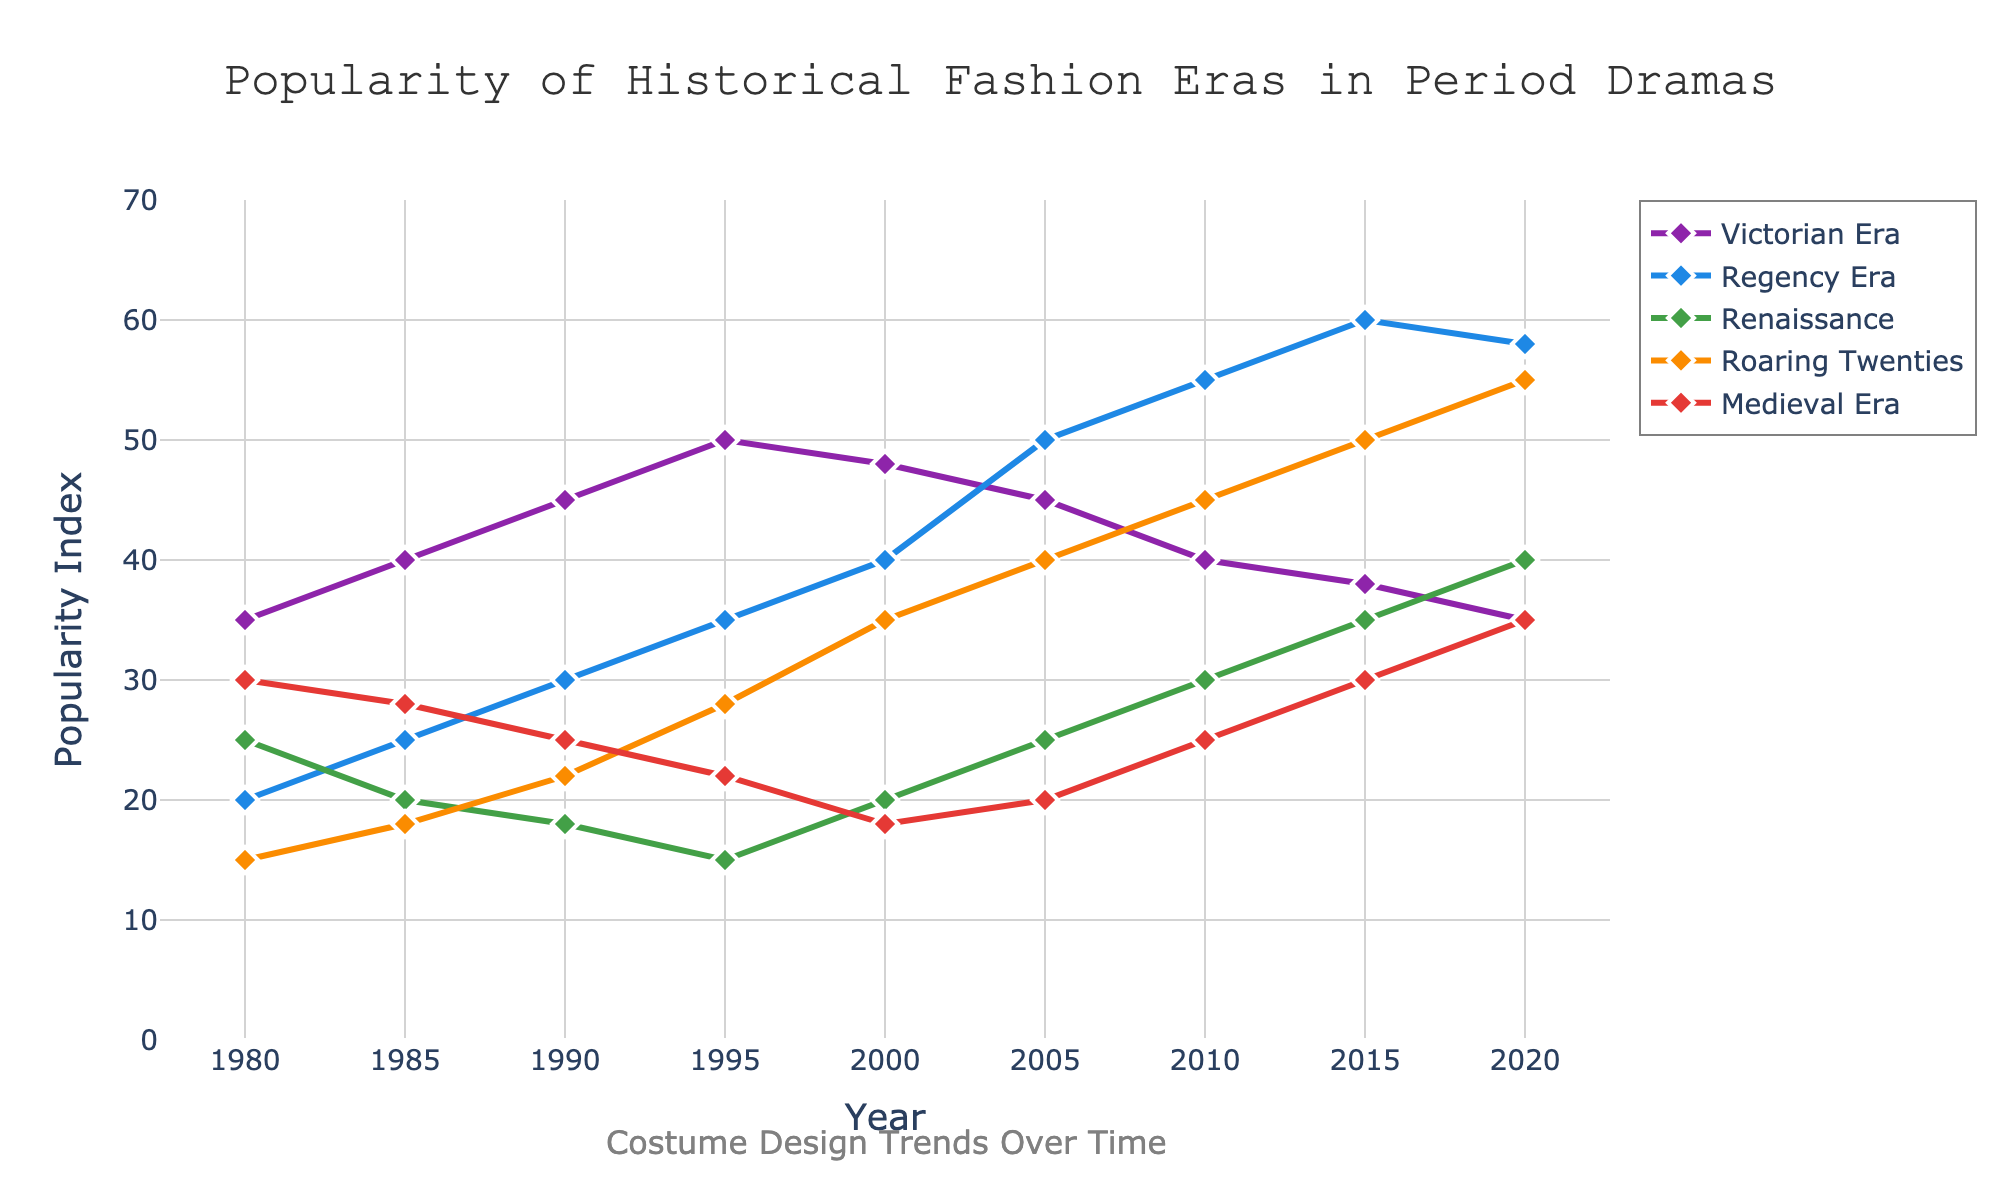What's the most popular fashion era in 2015? Based on the height of the lines at 2015, the Regency Era has the highest popularity index, where 60 is visibly the peak value.
Answer: Regency Era How does the popularity of the Roaring Twenties compare to the Medieval Era in 2020? By examining the endpoints of the lines in 2020, the Roaring Twenties fashion era has a higher popularity index of 55 compared to the Medieval Era’s index of 35.
Answer: Roaring Twenties is higher What year did the Victorian Era peak in popularity, and what was the index value? Observing the line for the Victorian Era, its highest point is in 1995, where the index value is 50.
Answer: 1995, 50 Which fashion era had a consistent increase in popularity from 1980 to 2015? Reviewing the overall trends for each line, the Regency Era shows a consistent increase from 20 in 1980 to 60 in 2015.
Answer: Regency Era What is the difference in popularity between the Renaissance and the Victorian Era in 2005? The popularity index for the Renaissance in 2005 is 25 and for the Victorian Era is 45. The difference is 45 - 25 = 20.
Answer: 20 In which year did the Roaring Twenties surpass the popularity of the Renaissance, and by how much? Comparing the lines for the Roaring Twenties and Renaissance, in 2010, the Roaring Twenties popularity index is 45, surpassing the Renaissance's 30. The difference is 45 - 30 = 15.
Answer: 2010, 15 What is the average popularity index of the Medieval Era from 1980 to 2020? Summing the values from 1980 to 2020 for the Medieval Era: 30, 28, 25, 22, 18, 20, 25, 30, 35, and then dividing by the number of years (9) gives (30 + 28 + 25 + 22 + 18 + 20 + 25 + 30 + 35) / 9 = 233 / 9 ≈ 25.89.
Answer: 25.89 